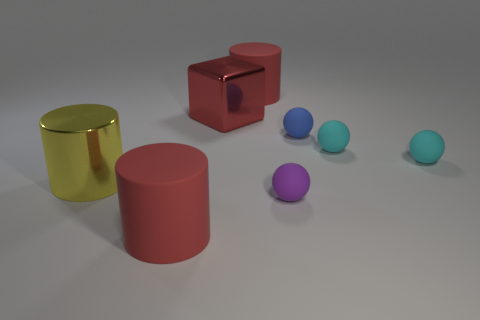What number of blue objects are either big balls or rubber things? In the image, there are three blue objects which appear to be balls. Since we can't determine the material from the image, we can't confirm if they're made of rubber, but typically balls like these often are. Thus, there are three blue objects that could possibly satisfy the criteria of being either big balls or rubber things. 